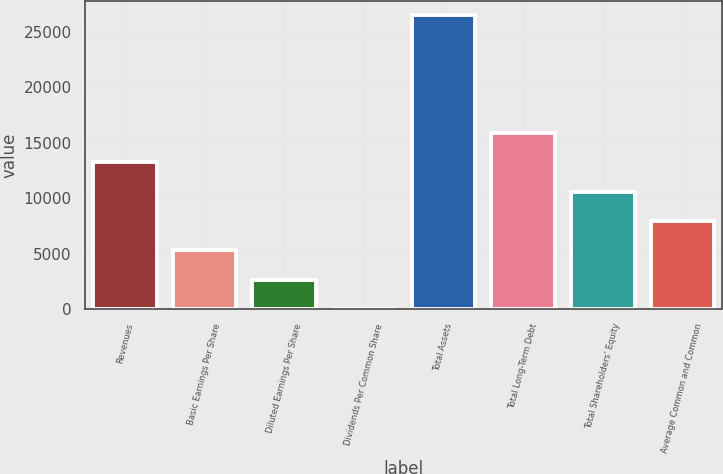Convert chart to OTSL. <chart><loc_0><loc_0><loc_500><loc_500><bar_chart><fcel>Revenues<fcel>Basic Earnings Per Share<fcel>Diluted Earnings Per Share<fcel>Dividends Per Common Share<fcel>Total Assets<fcel>Total Long-Term Debt<fcel>Total Shareholders' Equity<fcel>Average Common and Common<nl><fcel>13240.2<fcel>5297.52<fcel>2649.96<fcel>2.4<fcel>26478<fcel>15887.8<fcel>10592.6<fcel>7945.08<nl></chart> 